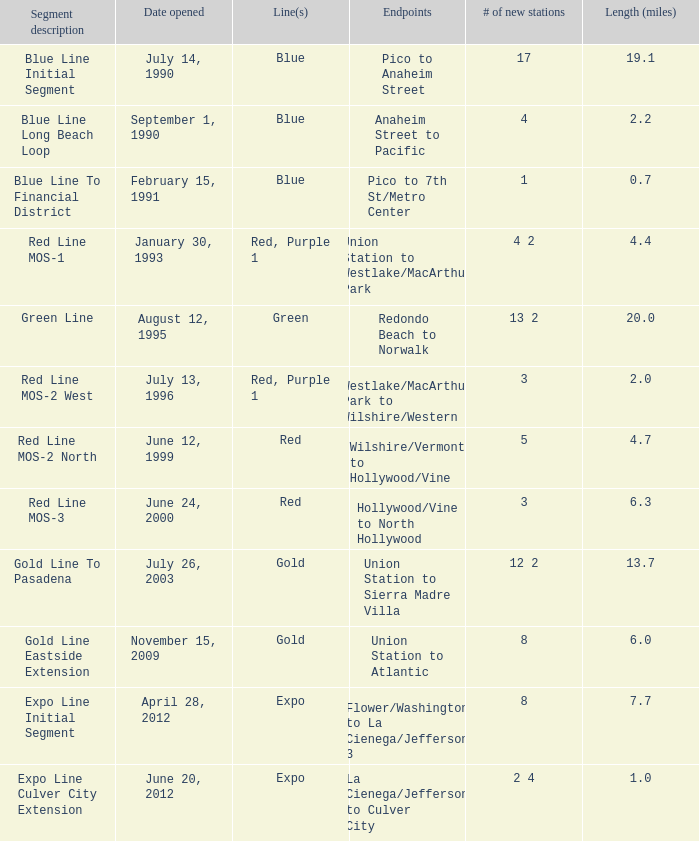What is the distance (miles) between westlake/macarthur park and wilshire/western? 2.0. 